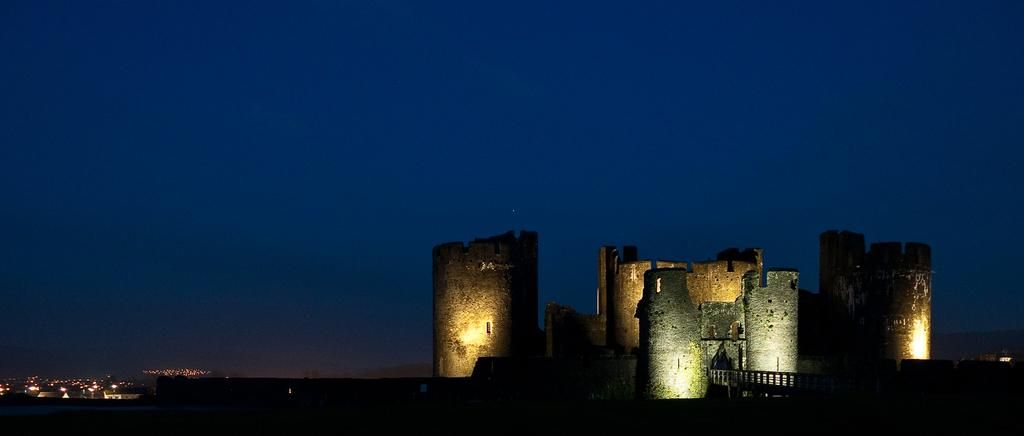What structures are present in the image? There are buildings in the image. What can be seen in the background of the image? The sky is visible in the background of the image. Where is the desk located in the image? There is no desk present in the image. What type of cloud can be seen in the image? There is no cloud visible in the image; only the sky is mentioned. 